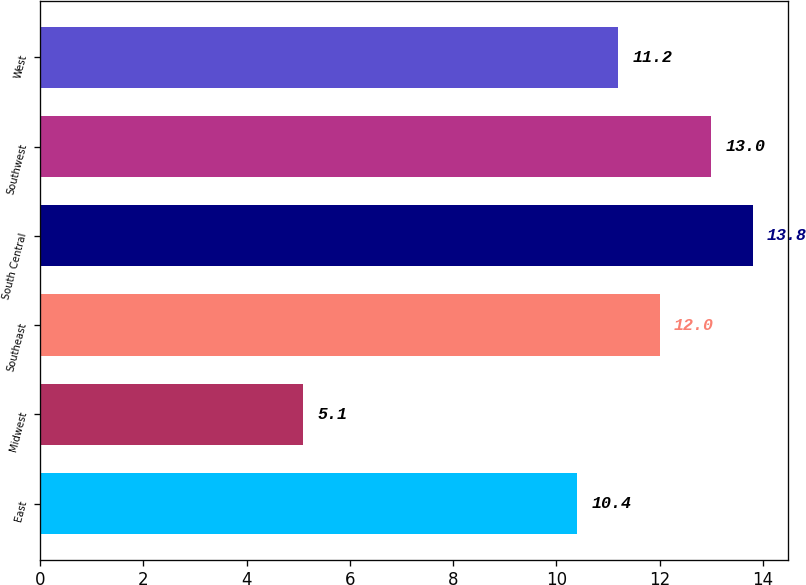Convert chart. <chart><loc_0><loc_0><loc_500><loc_500><bar_chart><fcel>East<fcel>Midwest<fcel>Southeast<fcel>South Central<fcel>Southwest<fcel>West<nl><fcel>10.4<fcel>5.1<fcel>12<fcel>13.8<fcel>13<fcel>11.2<nl></chart> 